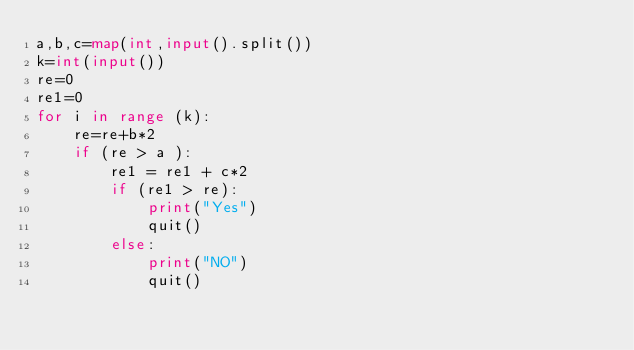<code> <loc_0><loc_0><loc_500><loc_500><_Python_>a,b,c=map(int,input().split())
k=int(input())
re=0
re1=0
for i in range (k):
    re=re+b*2
    if (re > a ):
        re1 = re1 + c*2
        if (re1 > re):
            print("Yes")
            quit()
        else:
            print("NO")
            quit()</code> 